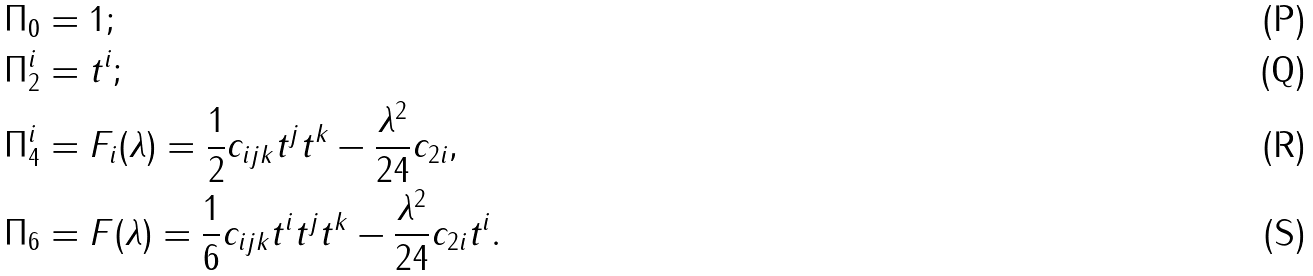Convert formula to latex. <formula><loc_0><loc_0><loc_500><loc_500>\Pi _ { 0 } & = 1 ; \\ \Pi _ { 2 } ^ { i } & = t ^ { i } ; \\ \Pi _ { 4 } ^ { i } & = F _ { i } ( \lambda ) = \frac { 1 } { 2 } c _ { i j k } t ^ { j } t ^ { k } - \frac { \lambda ^ { 2 } } { 2 4 } c _ { 2 i } , \\ \Pi _ { 6 } & = F ( \lambda ) = \frac { 1 } { 6 } c _ { i j k } t ^ { i } t ^ { j } t ^ { k } - \frac { \lambda ^ { 2 } } { 2 4 } c _ { 2 i } t ^ { i } .</formula> 